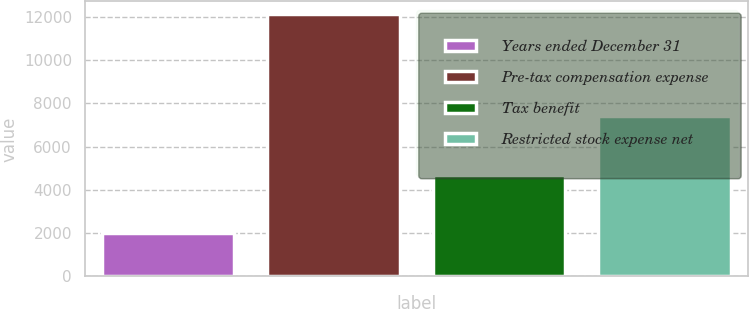<chart> <loc_0><loc_0><loc_500><loc_500><bar_chart><fcel>Years ended December 31<fcel>Pre-tax compensation expense<fcel>Tax benefit<fcel>Restricted stock expense net<nl><fcel>2015<fcel>12110<fcel>4687<fcel>7423<nl></chart> 